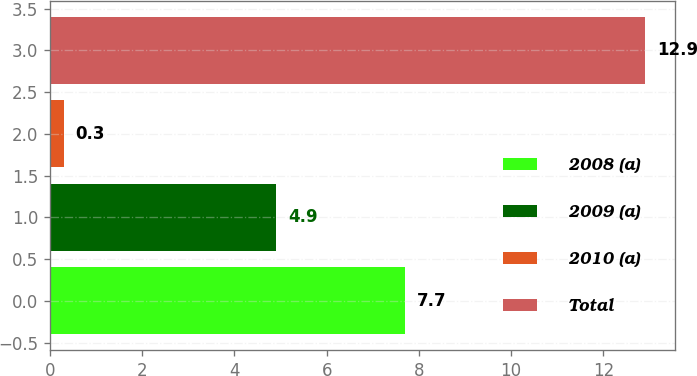Convert chart to OTSL. <chart><loc_0><loc_0><loc_500><loc_500><bar_chart><fcel>2008 (a)<fcel>2009 (a)<fcel>2010 (a)<fcel>Total<nl><fcel>7.7<fcel>4.9<fcel>0.3<fcel>12.9<nl></chart> 